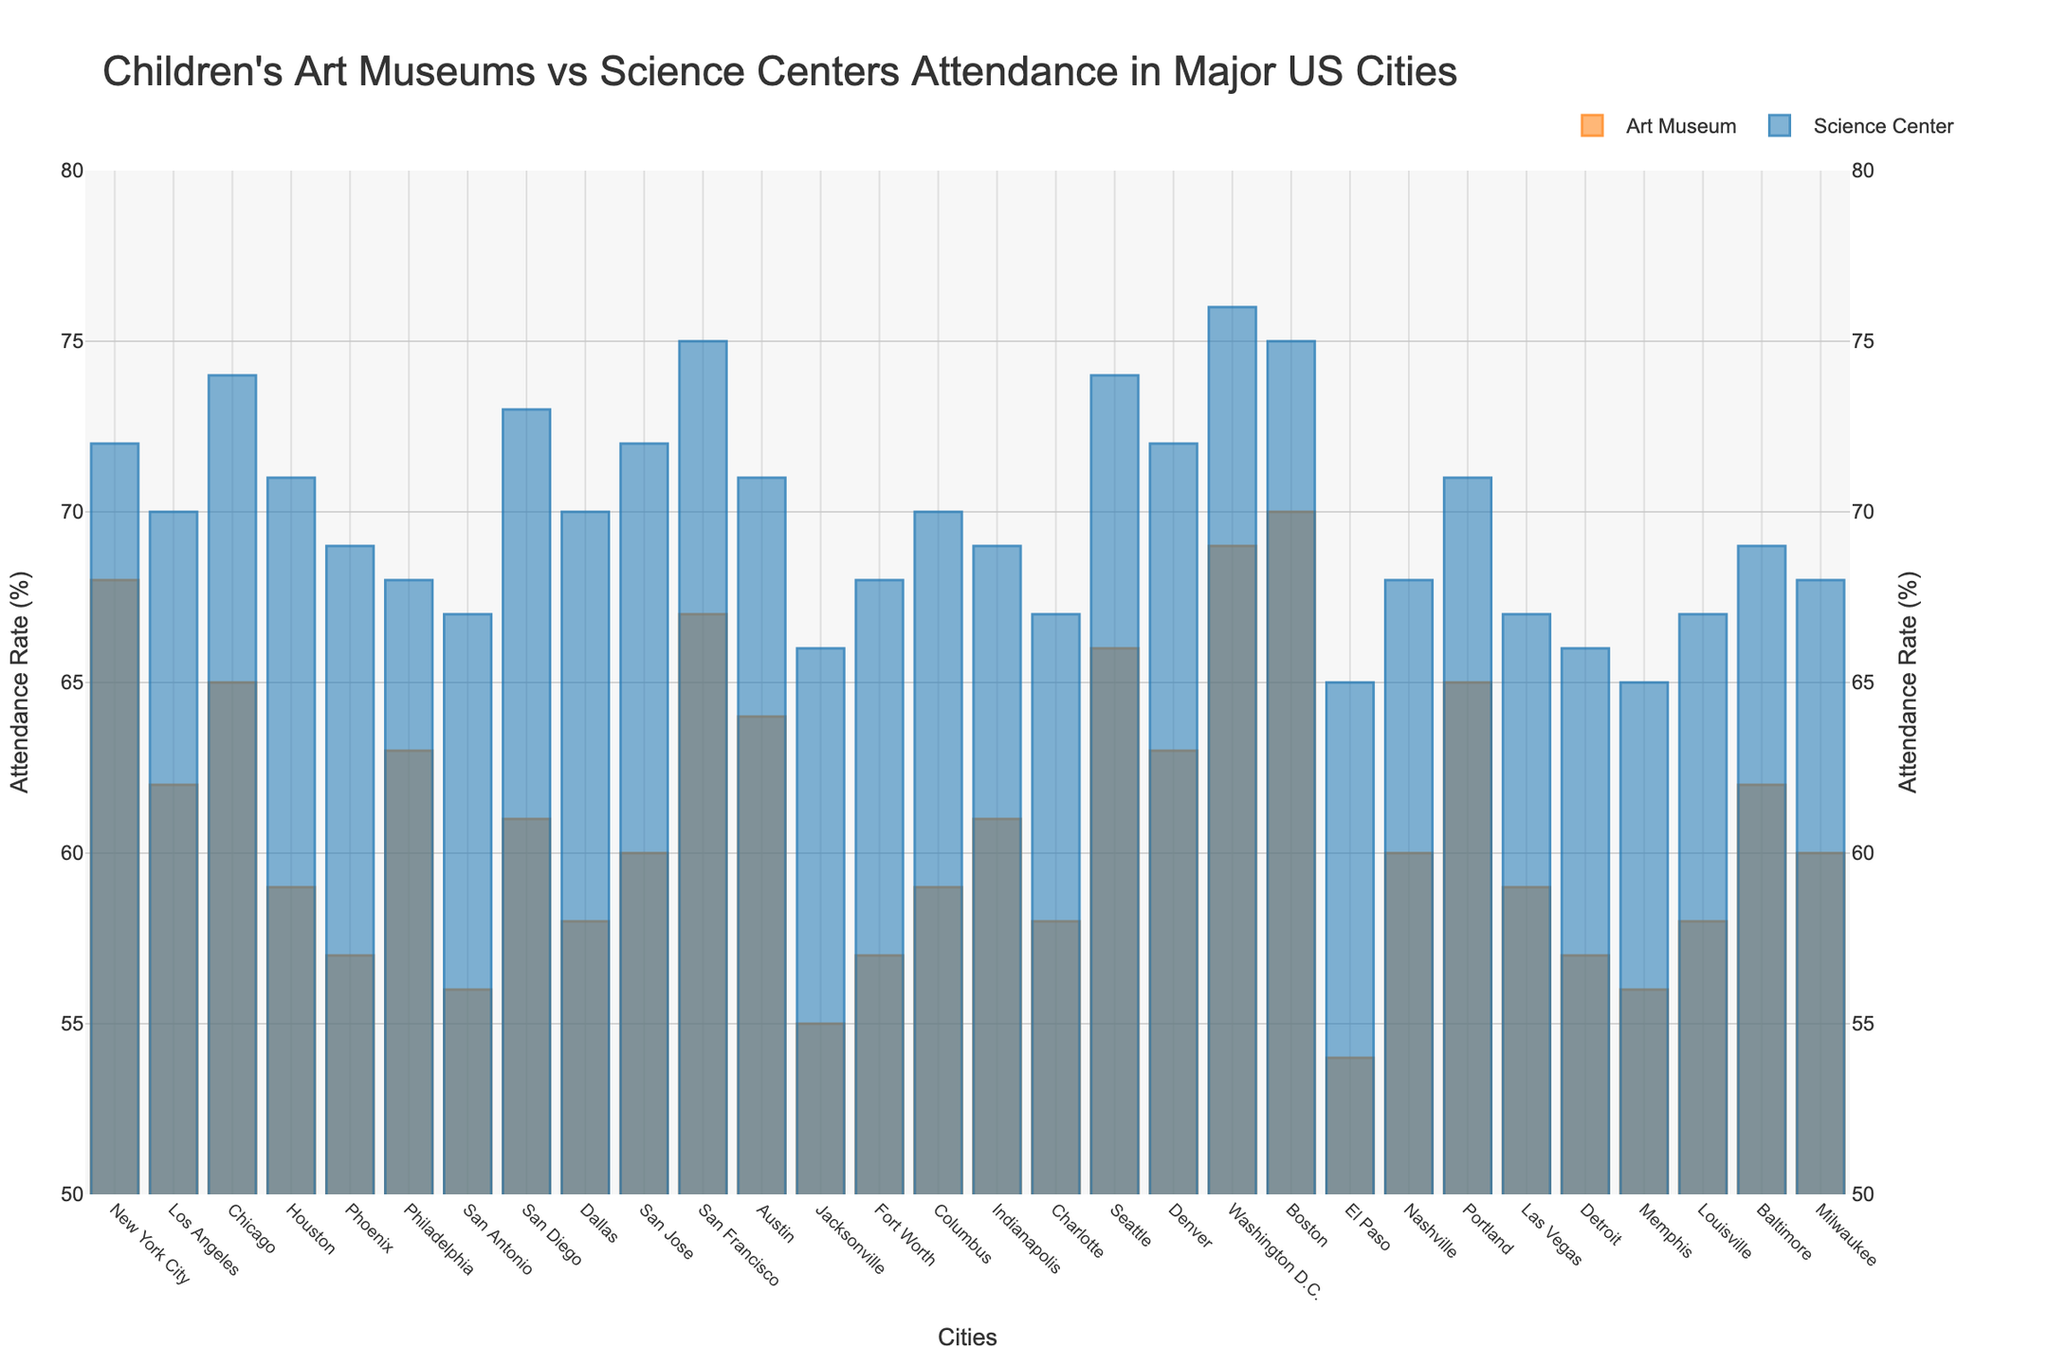What's the average attendance rate for children's art museums across all cities? To find the average attendance rate for art museums, sum all the attendance rates for the cities and then divide by the number of cities. Total sum = 68 + 62 + 65 + 59 + 57 + 63 + 56 + 61 + 58 + 60 + 67 + 64 + 55 + 57 + 59 + 61 + 58 + 66 + 63 + 69 + 70 + 54 + 60 + 65 + 59 + 57 + 56 + 58 + 62 + 60 = 1838. Number of cities = 30. Average = 1838 / 30 = 61.27
Answer: 61.27 Which city has the highest attendance rate at science centers? To determine the city with the highest attendance rate at science centers, review the attendance rate values and find the maximum. Washington D.C. has the highest attendance rate of 76%.
Answer: Washington D.C Is there any city where the art museum's attendance rate is equal to the science center's attendance rate? To find if there is any city where the attendance rates for both art museums and science centers are equal, compare both values for each city. Every city has different values for the two attendance rates.
Answer: No Which city has a higher attendance rate for art museums compared to science centers? We compare the attendance rates of art museums and science centers for each city. No city has a higher attendance rate for art museums than science centers.
Answer: None What is the attendance rate difference between the children’s art museum and the science center in Chicago? Subtract the attendance rate of the art museum from the science center in Chicago. Difference = 74 (Science Center) - 65 (Art Museum) = 9.
Answer: 9 In which cities are the attendance rates for both art museums and science centers above 70%? Identify cities where both attendance rates exceed 70%. New York City (Art Museum: 68, Science Center: 72), Chicago (65, 74), San Francisco (67, 75), Washington D.C. (69, 76), and Boston (70, 75). Only Washington D.C., San Francisco, and Boston meet the criteria for both.
Answer: Washington D.C., San Francisco, Boston 